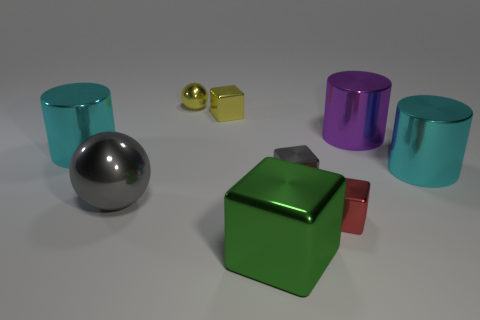Subtract all tiny yellow blocks. How many blocks are left? 3 Subtract all gray balls. How many cyan cylinders are left? 2 Add 1 tiny yellow rubber cubes. How many objects exist? 10 Subtract all gray cubes. How many cubes are left? 3 Subtract all blocks. How many objects are left? 5 Add 9 cyan matte cylinders. How many cyan matte cylinders exist? 9 Subtract 1 red cubes. How many objects are left? 8 Subtract all gray cylinders. Subtract all red cubes. How many cylinders are left? 3 Subtract all cubes. Subtract all tiny metal spheres. How many objects are left? 4 Add 3 cyan metal cylinders. How many cyan metal cylinders are left? 5 